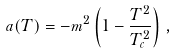<formula> <loc_0><loc_0><loc_500><loc_500>a ( T ) = - m ^ { 2 } \left ( 1 - \frac { T ^ { 2 } } { T _ { c } ^ { 2 } } \right ) \, ,</formula> 